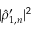Convert formula to latex. <formula><loc_0><loc_0><loc_500><loc_500>| \hat { \rho } _ { 1 , n } ^ { \prime } | ^ { 2 }</formula> 